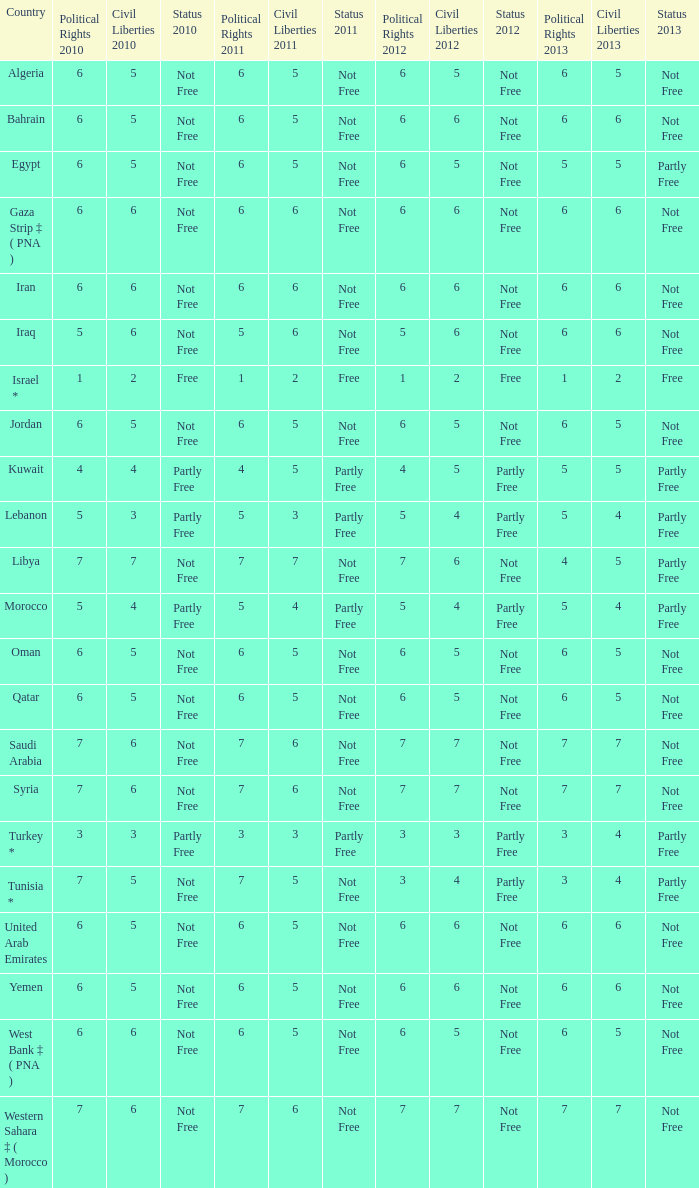What is the average 2012 civil liberties value associated with a 2011 status of not free, political rights 2012 over 6, and political rights 2011 over 7? None. 